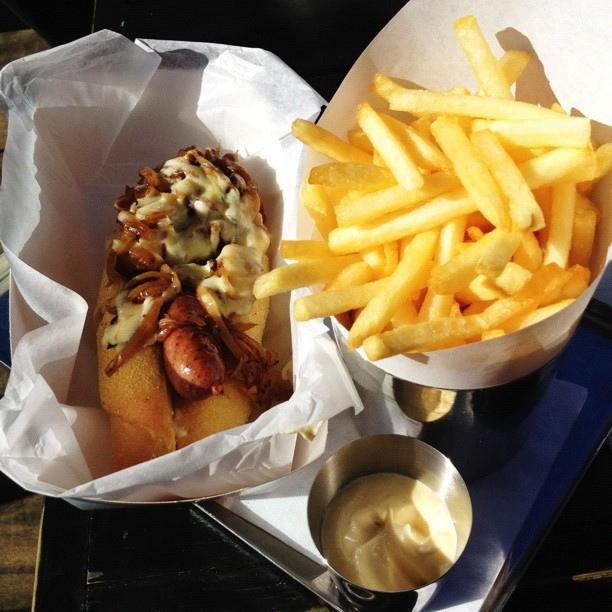How many bowls are visible?
Give a very brief answer. 2. How many people are wearing red pants?
Give a very brief answer. 0. 